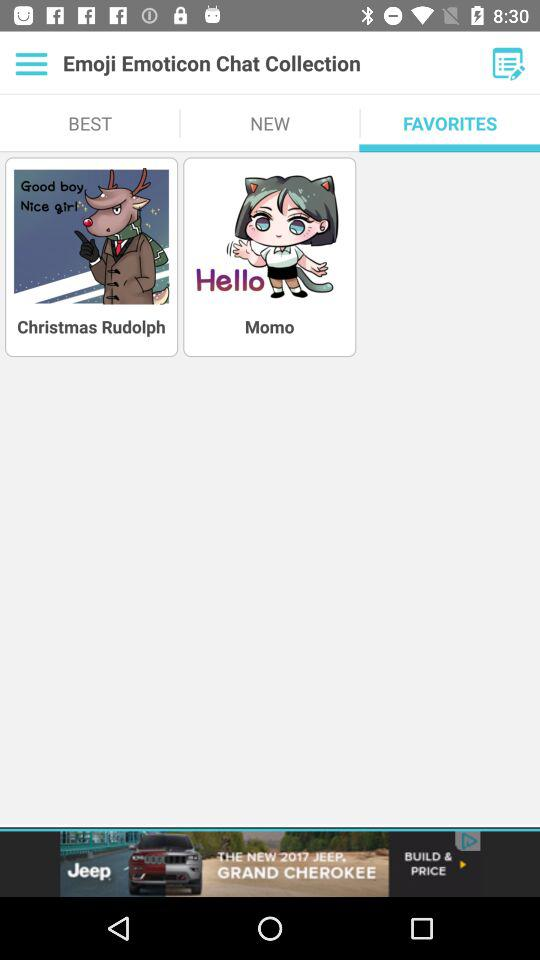Which tab is selected? The selected tab is "FAVORITES". 